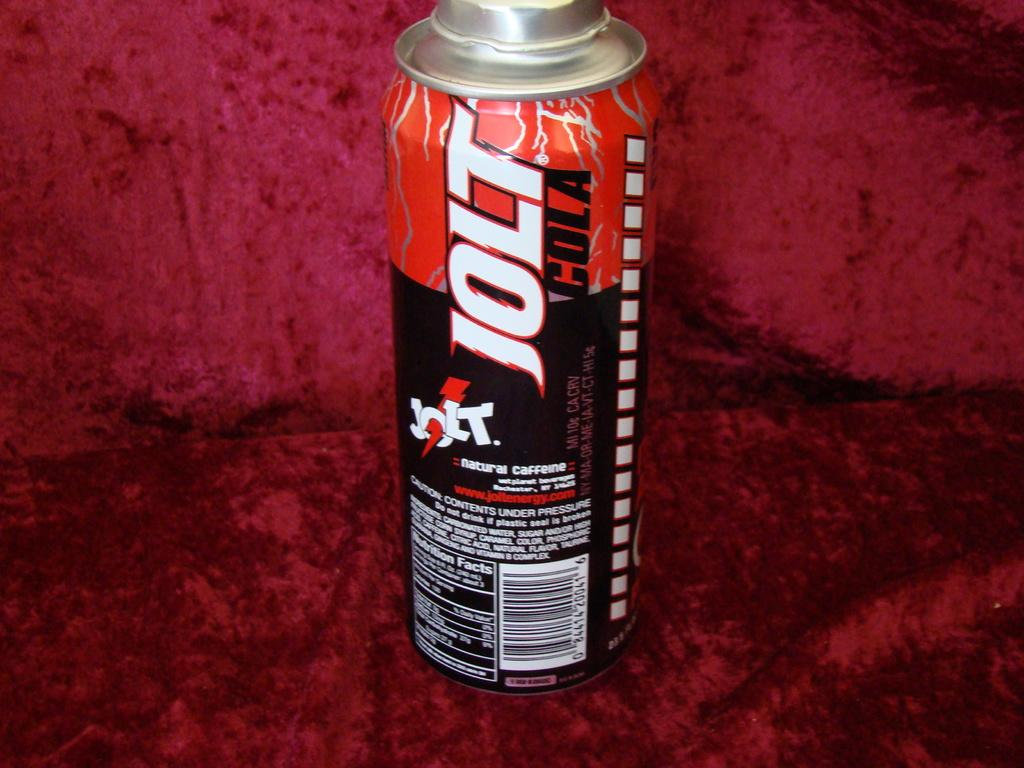<image>
Offer a succinct explanation of the picture presented. A tallboy can of Jolt Cola resting on a red velvet background. 